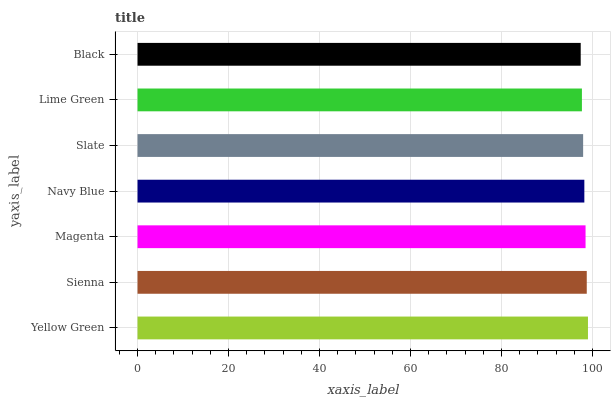Is Black the minimum?
Answer yes or no. Yes. Is Yellow Green the maximum?
Answer yes or no. Yes. Is Sienna the minimum?
Answer yes or no. No. Is Sienna the maximum?
Answer yes or no. No. Is Yellow Green greater than Sienna?
Answer yes or no. Yes. Is Sienna less than Yellow Green?
Answer yes or no. Yes. Is Sienna greater than Yellow Green?
Answer yes or no. No. Is Yellow Green less than Sienna?
Answer yes or no. No. Is Navy Blue the high median?
Answer yes or no. Yes. Is Navy Blue the low median?
Answer yes or no. Yes. Is Lime Green the high median?
Answer yes or no. No. Is Lime Green the low median?
Answer yes or no. No. 